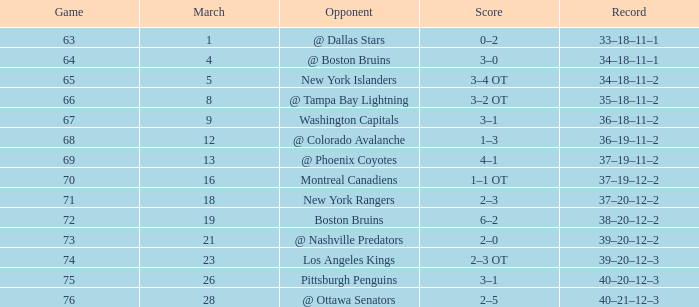Which game has the highest ranking, with points under 92 and a score between 1 and 3? 68.0. 